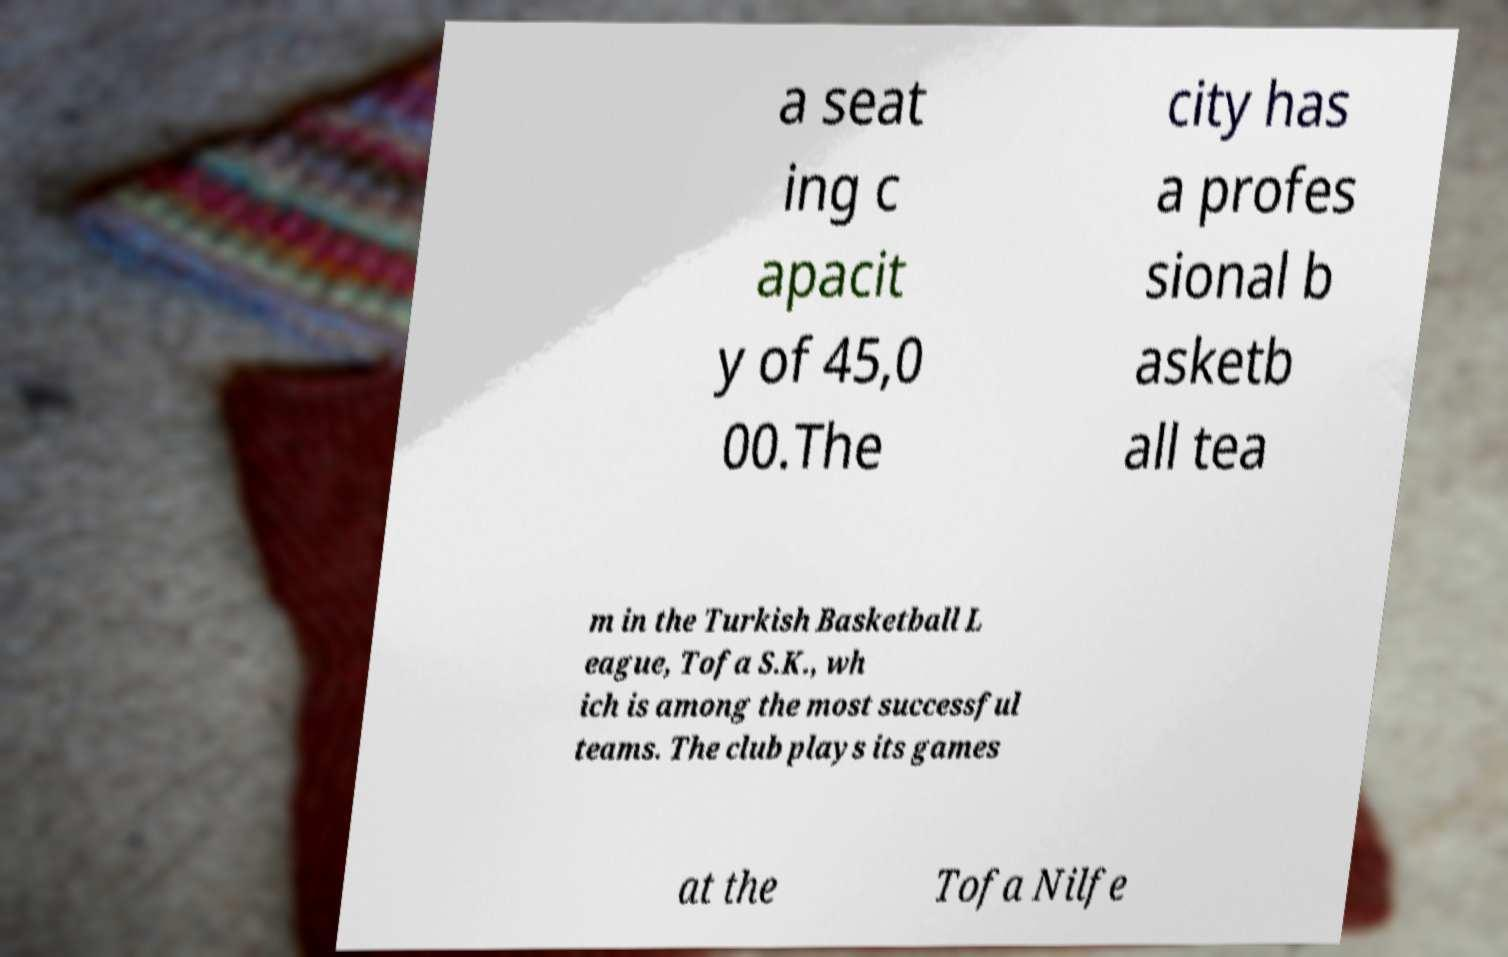Please identify and transcribe the text found in this image. a seat ing c apacit y of 45,0 00.The city has a profes sional b asketb all tea m in the Turkish Basketball L eague, Tofa S.K., wh ich is among the most successful teams. The club plays its games at the Tofa Nilfe 